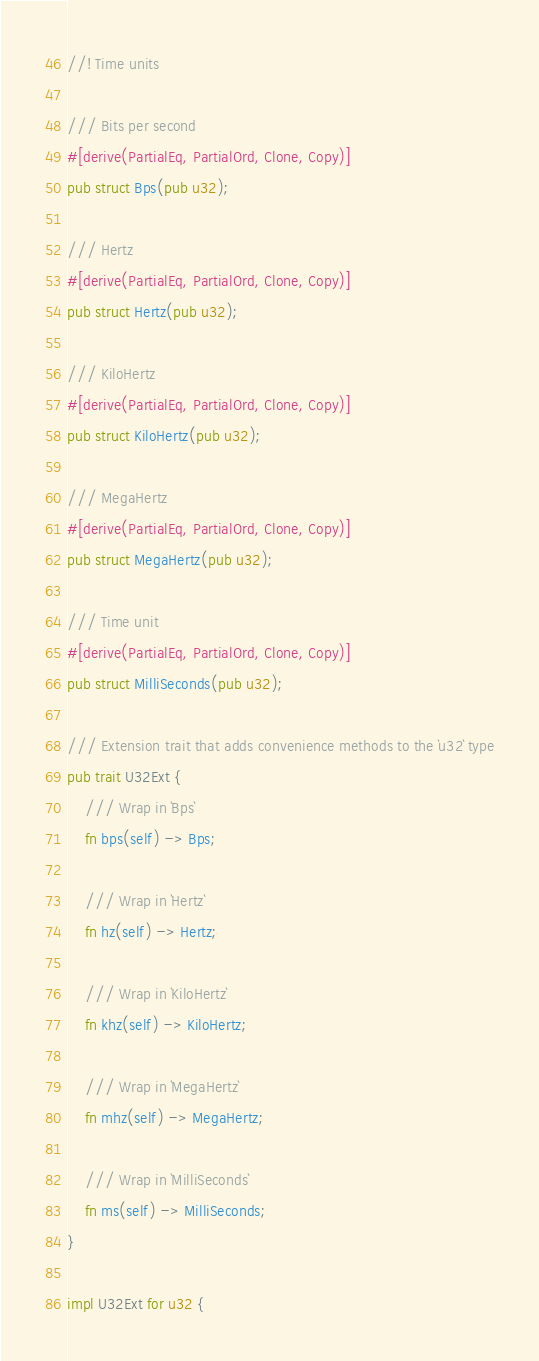Convert code to text. <code><loc_0><loc_0><loc_500><loc_500><_Rust_>//! Time units

/// Bits per second
#[derive(PartialEq, PartialOrd, Clone, Copy)]
pub struct Bps(pub u32);

/// Hertz
#[derive(PartialEq, PartialOrd, Clone, Copy)]
pub struct Hertz(pub u32);

/// KiloHertz
#[derive(PartialEq, PartialOrd, Clone, Copy)]
pub struct KiloHertz(pub u32);

/// MegaHertz
#[derive(PartialEq, PartialOrd, Clone, Copy)]
pub struct MegaHertz(pub u32);

/// Time unit
#[derive(PartialEq, PartialOrd, Clone, Copy)]
pub struct MilliSeconds(pub u32);

/// Extension trait that adds convenience methods to the `u32` type
pub trait U32Ext {
    /// Wrap in `Bps`
    fn bps(self) -> Bps;

    /// Wrap in `Hertz`
    fn hz(self) -> Hertz;

    /// Wrap in `KiloHertz`
    fn khz(self) -> KiloHertz;

    /// Wrap in `MegaHertz`
    fn mhz(self) -> MegaHertz;

    /// Wrap in `MilliSeconds`
    fn ms(self) -> MilliSeconds;
}

impl U32Ext for u32 {</code> 